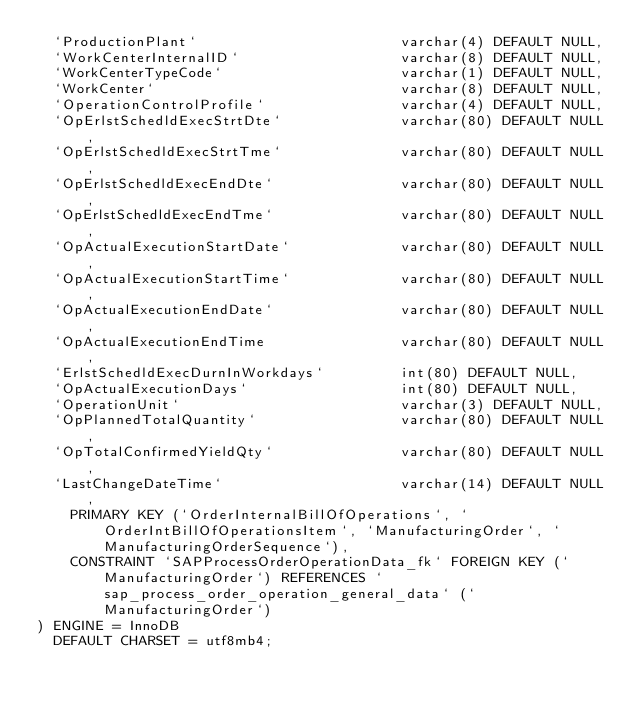Convert code to text. <code><loc_0><loc_0><loc_500><loc_500><_SQL_>	`ProductionPlant`                        varchar(4) DEFAULT NULL,
	`WorkCenterInternalID`                   varchar(8) DEFAULT NULL,
	`WorkCenterTypeCode`                     varchar(1) DEFAULT NULL,
	`WorkCenter`                             varchar(8) DEFAULT NULL,
	`OperationControlProfile`                varchar(4) DEFAULT NULL,
	`OpErlstSchedldExecStrtDte`              varchar(80) DEFAULT NULL,
	`OpErlstSchedldExecStrtTme`              varchar(80) DEFAULT NULL,
	`OpErlstSchedldExecEndDte`               varchar(80) DEFAULT NULL,
	`OpErlstSchedldExecEndTme`               varchar(80) DEFAULT NULL,
	`OpActualExecutionStartDate`             varchar(80) DEFAULT NULL,
	`OpActualExecutionStartTime`             varchar(80) DEFAULT NULL,
	`OpActualExecutionEndDate`               varchar(80) DEFAULT NULL,
	`OpActualExecutionEndTime                varchar(80) DEFAULT NULL,
	`ErlstSchedldExecDurnInWorkdays`         int(80) DEFAULT NULL,
	`OpActualExecutionDays`                  int(80) DEFAULT NULL,
	`OperationUnit`                          varchar(3) DEFAULT NULL,
	`OpPlannedTotalQuantity`                 varchar(80) DEFAULT NULL,
	`OpTotalConfirmedYieldQty`               varchar(80) DEFAULT NULL,
	`LastChangeDateTime`                     varchar(14) DEFAULT NULL,
    PRIMARY KEY (`OrderInternalBillOfOperations`, `OrderIntBillOfOperationsItem`, `ManufacturingOrder`, `ManufacturingOrderSequence`),
    CONSTRAINT `SAPProcessOrderOperationData_fk` FOREIGN KEY (`ManufacturingOrder`) REFERENCES `sap_process_order_operation_general_data` (`ManufacturingOrder`)
) ENGINE = InnoDB
  DEFAULT CHARSET = utf8mb4;</code> 